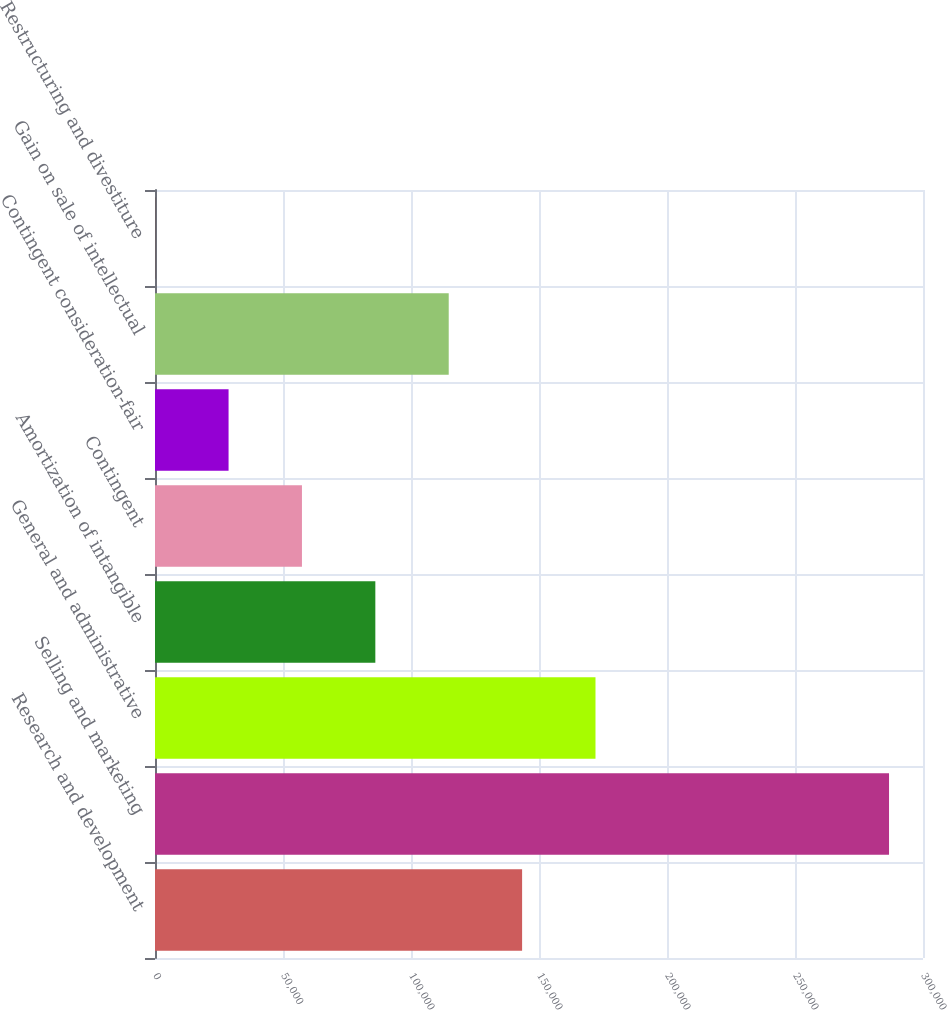Convert chart. <chart><loc_0><loc_0><loc_500><loc_500><bar_chart><fcel>Research and development<fcel>Selling and marketing<fcel>General and administrative<fcel>Amortization of intangible<fcel>Contingent<fcel>Contingent consideration-fair<fcel>Gain on sale of intellectual<fcel>Restructuring and divestiture<nl><fcel>143400<fcel>286730<fcel>172066<fcel>86068.7<fcel>57402.8<fcel>28736.9<fcel>114735<fcel>71<nl></chart> 